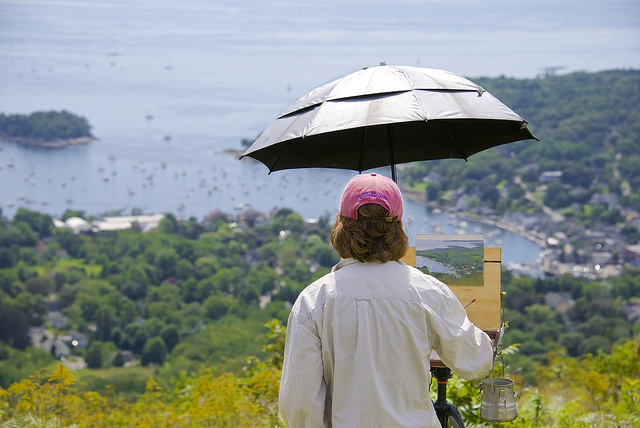Describe the objects in this image and their specific colors. I can see people in darkgray, black, gray, and lightgray tones, umbrella in darkgray, black, and lightgray tones, boat in darkgray, lightgray, and gray tones, boat in darkgray and gray tones, and boat in darkgray, lightgray, and lavender tones in this image. 